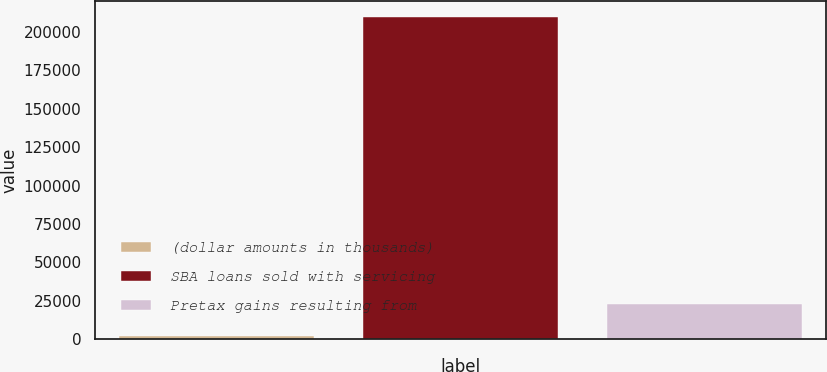<chart> <loc_0><loc_0><loc_500><loc_500><bar_chart><fcel>(dollar amounts in thousands)<fcel>SBA loans sold with servicing<fcel>Pretax gains resulting from<nl><fcel>2012<fcel>209540<fcel>22916<nl></chart> 